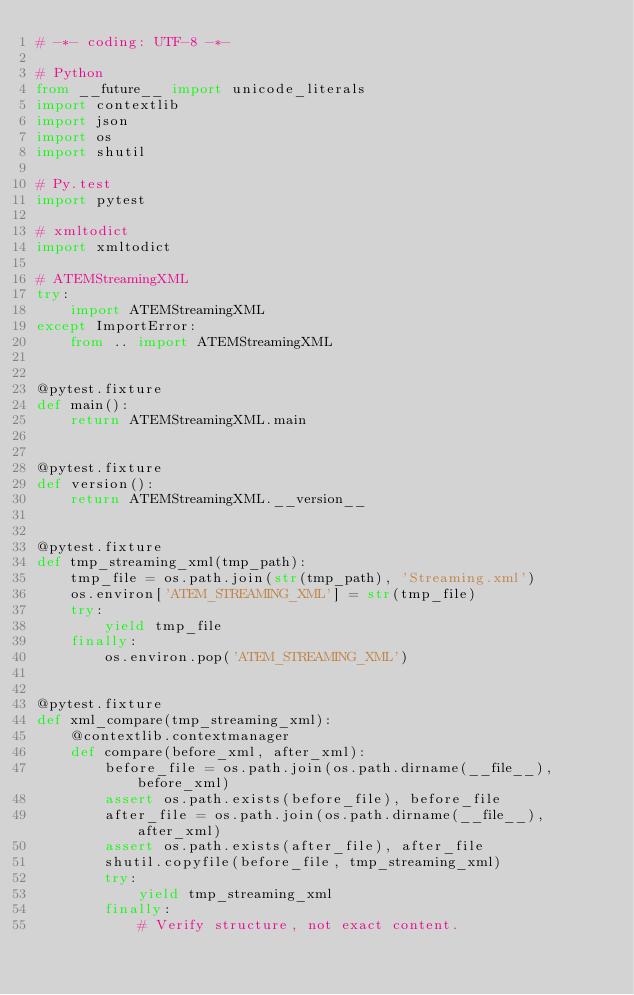<code> <loc_0><loc_0><loc_500><loc_500><_Python_># -*- coding: UTF-8 -*-

# Python
from __future__ import unicode_literals
import contextlib
import json
import os
import shutil

# Py.test
import pytest

# xmltodict
import xmltodict

# ATEMStreamingXML
try:
    import ATEMStreamingXML
except ImportError:
    from .. import ATEMStreamingXML


@pytest.fixture
def main():
    return ATEMStreamingXML.main


@pytest.fixture
def version():
    return ATEMStreamingXML.__version__


@pytest.fixture
def tmp_streaming_xml(tmp_path):
    tmp_file = os.path.join(str(tmp_path), 'Streaming.xml')
    os.environ['ATEM_STREAMING_XML'] = str(tmp_file)
    try:
        yield tmp_file
    finally:
        os.environ.pop('ATEM_STREAMING_XML')


@pytest.fixture
def xml_compare(tmp_streaming_xml):
    @contextlib.contextmanager
    def compare(before_xml, after_xml):
        before_file = os.path.join(os.path.dirname(__file__), before_xml)
        assert os.path.exists(before_file), before_file
        after_file = os.path.join(os.path.dirname(__file__), after_xml)
        assert os.path.exists(after_file), after_file
        shutil.copyfile(before_file, tmp_streaming_xml)
        try:
            yield tmp_streaming_xml
        finally:
            # Verify structure, not exact content.</code> 